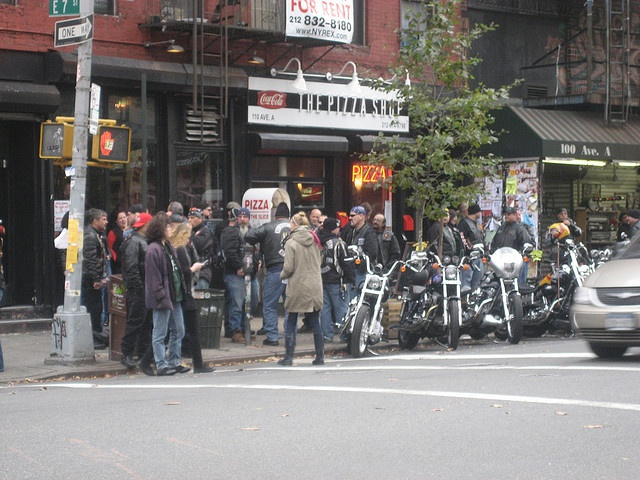Describe the objects in this image and their specific colors. I can see people in gray, black, and darkgray tones, car in gray, lightgray, darkgray, and black tones, people in gray, black, and darkgray tones, people in gray and darkgray tones, and motorcycle in gray, white, black, and darkgray tones in this image. 